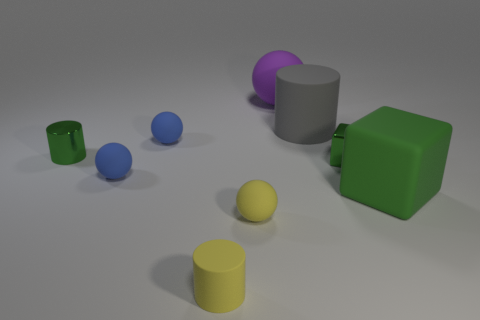How would you describe the lighting and atmosphere of this scene? The lighting in the scene is soft and seems to be coming from above, casting gentle shadows that give the objects a three-dimensional appearance. The atmosphere feels quiet and neutral, with a simple background that does not distract from the objects. 